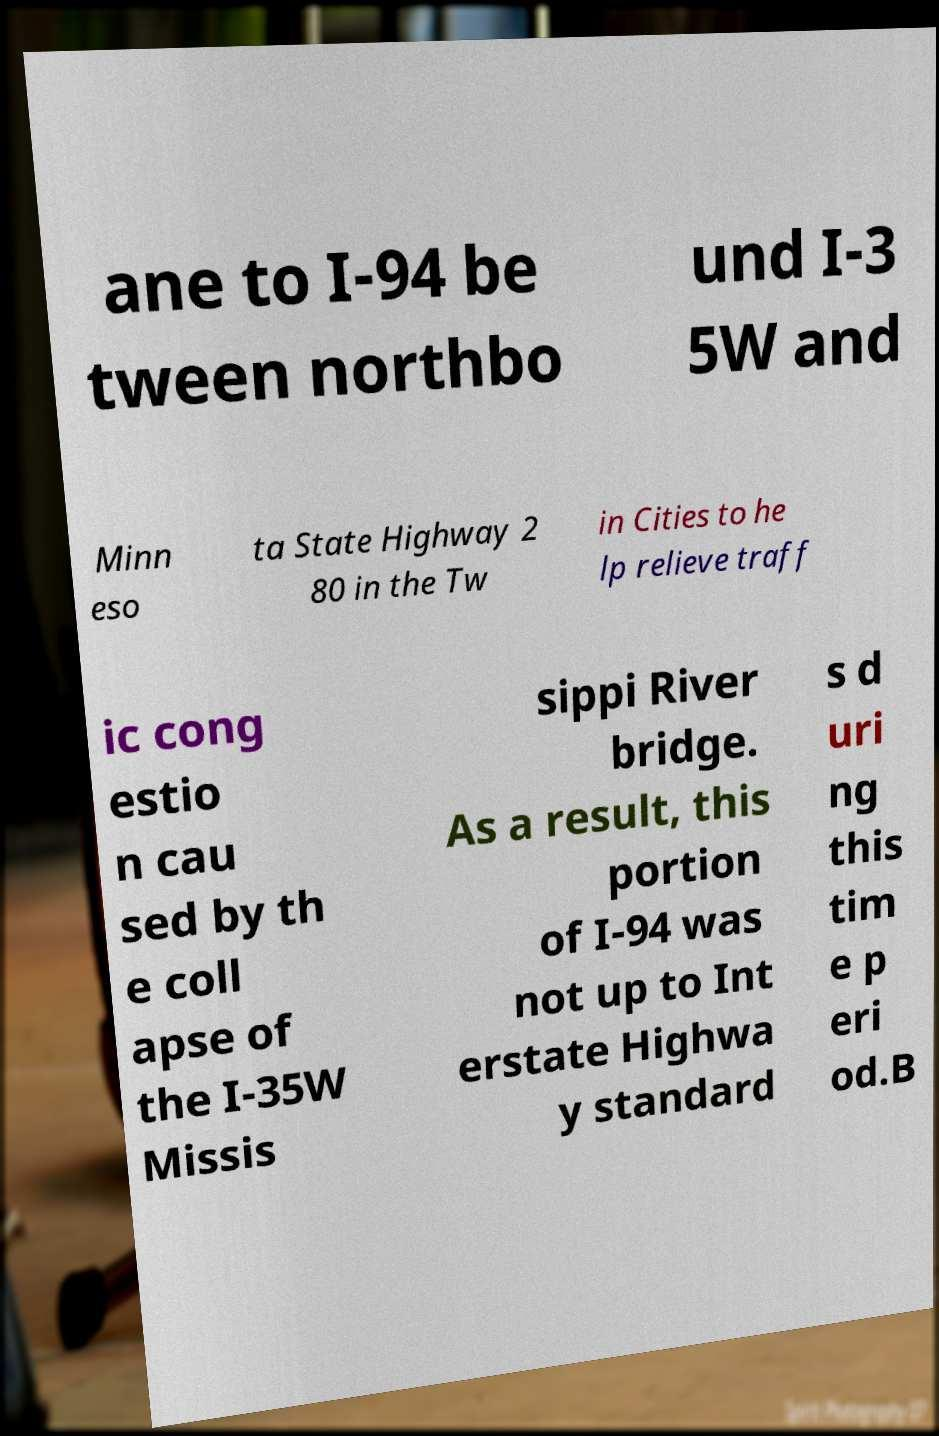What messages or text are displayed in this image? I need them in a readable, typed format. ane to I-94 be tween northbo und I-3 5W and Minn eso ta State Highway 2 80 in the Tw in Cities to he lp relieve traff ic cong estio n cau sed by th e coll apse of the I-35W Missis sippi River bridge. As a result, this portion of I-94 was not up to Int erstate Highwa y standard s d uri ng this tim e p eri od.B 